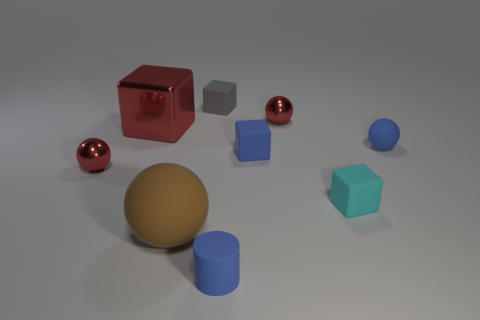Subtract all tiny gray matte cubes. How many cubes are left? 3 Subtract all red cylinders. How many red spheres are left? 2 Subtract all cyan blocks. How many blocks are left? 3 Subtract 2 spheres. How many spheres are left? 2 Subtract all cylinders. How many objects are left? 8 Add 5 small blue things. How many small blue things exist? 8 Subtract 1 blue cylinders. How many objects are left? 8 Subtract all purple blocks. Subtract all gray cylinders. How many blocks are left? 4 Subtract all large rubber cubes. Subtract all small blue matte objects. How many objects are left? 6 Add 3 large matte things. How many large matte things are left? 4 